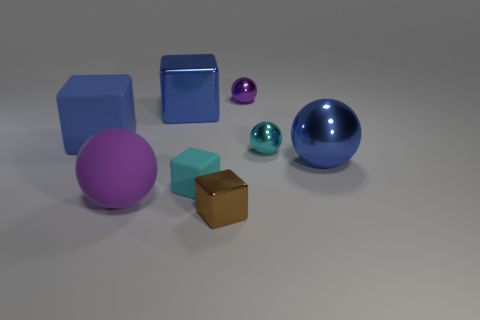Is the number of tiny cyan objects that are left of the big blue rubber object the same as the number of tiny cyan rubber things that are behind the purple matte object? no 